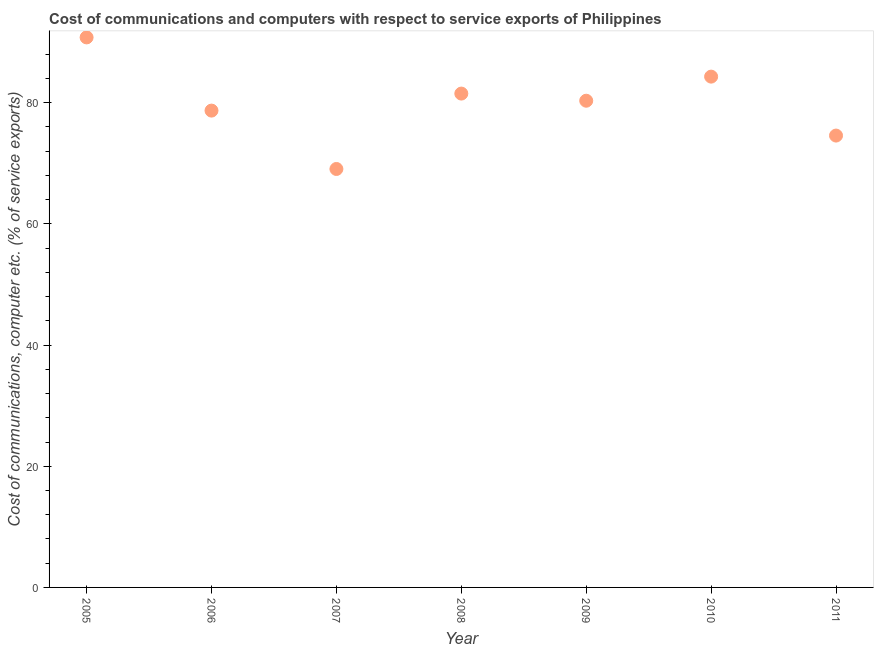What is the cost of communications and computer in 2009?
Keep it short and to the point. 80.33. Across all years, what is the maximum cost of communications and computer?
Ensure brevity in your answer.  90.78. Across all years, what is the minimum cost of communications and computer?
Keep it short and to the point. 69.06. In which year was the cost of communications and computer maximum?
Provide a short and direct response. 2005. In which year was the cost of communications and computer minimum?
Offer a very short reply. 2007. What is the sum of the cost of communications and computer?
Offer a terse response. 559.24. What is the difference between the cost of communications and computer in 2005 and 2007?
Make the answer very short. 21.72. What is the average cost of communications and computer per year?
Offer a terse response. 79.89. What is the median cost of communications and computer?
Give a very brief answer. 80.33. In how many years, is the cost of communications and computer greater than 20 %?
Your response must be concise. 7. What is the ratio of the cost of communications and computer in 2008 to that in 2009?
Provide a short and direct response. 1.01. What is the difference between the highest and the second highest cost of communications and computer?
Give a very brief answer. 6.47. What is the difference between the highest and the lowest cost of communications and computer?
Provide a succinct answer. 21.72. In how many years, is the cost of communications and computer greater than the average cost of communications and computer taken over all years?
Your answer should be compact. 4. What is the difference between two consecutive major ticks on the Y-axis?
Offer a terse response. 20. Are the values on the major ticks of Y-axis written in scientific E-notation?
Provide a succinct answer. No. What is the title of the graph?
Your answer should be compact. Cost of communications and computers with respect to service exports of Philippines. What is the label or title of the Y-axis?
Your answer should be compact. Cost of communications, computer etc. (% of service exports). What is the Cost of communications, computer etc. (% of service exports) in 2005?
Ensure brevity in your answer.  90.78. What is the Cost of communications, computer etc. (% of service exports) in 2006?
Your answer should be very brief. 78.7. What is the Cost of communications, computer etc. (% of service exports) in 2007?
Your answer should be compact. 69.06. What is the Cost of communications, computer etc. (% of service exports) in 2008?
Make the answer very short. 81.51. What is the Cost of communications, computer etc. (% of service exports) in 2009?
Make the answer very short. 80.33. What is the Cost of communications, computer etc. (% of service exports) in 2010?
Provide a short and direct response. 84.3. What is the Cost of communications, computer etc. (% of service exports) in 2011?
Ensure brevity in your answer.  74.57. What is the difference between the Cost of communications, computer etc. (% of service exports) in 2005 and 2006?
Provide a short and direct response. 12.08. What is the difference between the Cost of communications, computer etc. (% of service exports) in 2005 and 2007?
Provide a short and direct response. 21.71. What is the difference between the Cost of communications, computer etc. (% of service exports) in 2005 and 2008?
Ensure brevity in your answer.  9.27. What is the difference between the Cost of communications, computer etc. (% of service exports) in 2005 and 2009?
Offer a very short reply. 10.45. What is the difference between the Cost of communications, computer etc. (% of service exports) in 2005 and 2010?
Your answer should be very brief. 6.47. What is the difference between the Cost of communications, computer etc. (% of service exports) in 2005 and 2011?
Your answer should be compact. 16.2. What is the difference between the Cost of communications, computer etc. (% of service exports) in 2006 and 2007?
Offer a very short reply. 9.63. What is the difference between the Cost of communications, computer etc. (% of service exports) in 2006 and 2008?
Provide a short and direct response. -2.81. What is the difference between the Cost of communications, computer etc. (% of service exports) in 2006 and 2009?
Ensure brevity in your answer.  -1.63. What is the difference between the Cost of communications, computer etc. (% of service exports) in 2006 and 2010?
Your response must be concise. -5.61. What is the difference between the Cost of communications, computer etc. (% of service exports) in 2006 and 2011?
Offer a very short reply. 4.12. What is the difference between the Cost of communications, computer etc. (% of service exports) in 2007 and 2008?
Offer a very short reply. -12.44. What is the difference between the Cost of communications, computer etc. (% of service exports) in 2007 and 2009?
Provide a short and direct response. -11.26. What is the difference between the Cost of communications, computer etc. (% of service exports) in 2007 and 2010?
Make the answer very short. -15.24. What is the difference between the Cost of communications, computer etc. (% of service exports) in 2007 and 2011?
Your response must be concise. -5.51. What is the difference between the Cost of communications, computer etc. (% of service exports) in 2008 and 2009?
Keep it short and to the point. 1.18. What is the difference between the Cost of communications, computer etc. (% of service exports) in 2008 and 2010?
Offer a terse response. -2.8. What is the difference between the Cost of communications, computer etc. (% of service exports) in 2008 and 2011?
Provide a succinct answer. 6.93. What is the difference between the Cost of communications, computer etc. (% of service exports) in 2009 and 2010?
Give a very brief answer. -3.98. What is the difference between the Cost of communications, computer etc. (% of service exports) in 2009 and 2011?
Make the answer very short. 5.75. What is the difference between the Cost of communications, computer etc. (% of service exports) in 2010 and 2011?
Give a very brief answer. 9.73. What is the ratio of the Cost of communications, computer etc. (% of service exports) in 2005 to that in 2006?
Make the answer very short. 1.15. What is the ratio of the Cost of communications, computer etc. (% of service exports) in 2005 to that in 2007?
Give a very brief answer. 1.31. What is the ratio of the Cost of communications, computer etc. (% of service exports) in 2005 to that in 2008?
Your answer should be very brief. 1.11. What is the ratio of the Cost of communications, computer etc. (% of service exports) in 2005 to that in 2009?
Offer a terse response. 1.13. What is the ratio of the Cost of communications, computer etc. (% of service exports) in 2005 to that in 2010?
Make the answer very short. 1.08. What is the ratio of the Cost of communications, computer etc. (% of service exports) in 2005 to that in 2011?
Make the answer very short. 1.22. What is the ratio of the Cost of communications, computer etc. (% of service exports) in 2006 to that in 2007?
Provide a succinct answer. 1.14. What is the ratio of the Cost of communications, computer etc. (% of service exports) in 2006 to that in 2008?
Provide a short and direct response. 0.97. What is the ratio of the Cost of communications, computer etc. (% of service exports) in 2006 to that in 2009?
Offer a very short reply. 0.98. What is the ratio of the Cost of communications, computer etc. (% of service exports) in 2006 to that in 2010?
Give a very brief answer. 0.93. What is the ratio of the Cost of communications, computer etc. (% of service exports) in 2006 to that in 2011?
Provide a short and direct response. 1.05. What is the ratio of the Cost of communications, computer etc. (% of service exports) in 2007 to that in 2008?
Make the answer very short. 0.85. What is the ratio of the Cost of communications, computer etc. (% of service exports) in 2007 to that in 2009?
Give a very brief answer. 0.86. What is the ratio of the Cost of communications, computer etc. (% of service exports) in 2007 to that in 2010?
Ensure brevity in your answer.  0.82. What is the ratio of the Cost of communications, computer etc. (% of service exports) in 2007 to that in 2011?
Your answer should be compact. 0.93. What is the ratio of the Cost of communications, computer etc. (% of service exports) in 2008 to that in 2010?
Your response must be concise. 0.97. What is the ratio of the Cost of communications, computer etc. (% of service exports) in 2008 to that in 2011?
Give a very brief answer. 1.09. What is the ratio of the Cost of communications, computer etc. (% of service exports) in 2009 to that in 2010?
Your response must be concise. 0.95. What is the ratio of the Cost of communications, computer etc. (% of service exports) in 2009 to that in 2011?
Offer a terse response. 1.08. What is the ratio of the Cost of communications, computer etc. (% of service exports) in 2010 to that in 2011?
Give a very brief answer. 1.13. 